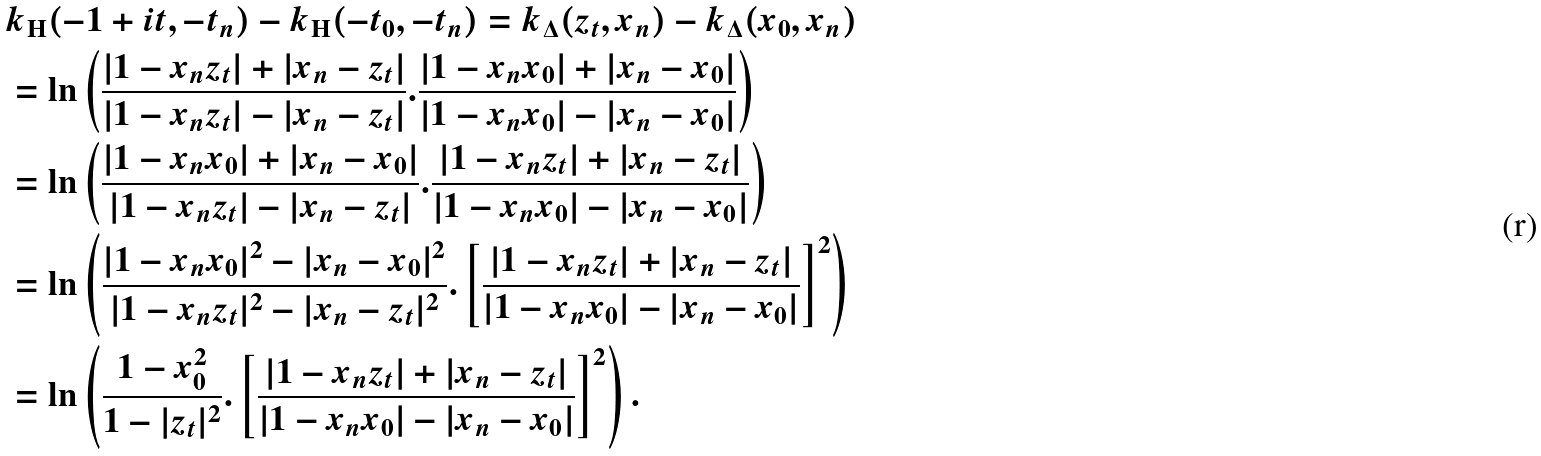<formula> <loc_0><loc_0><loc_500><loc_500>& k _ { \mathrm H } ( - 1 + i t , - t _ { n } ) - k _ { \mathrm H } ( - t _ { 0 } , - t _ { n } ) = k _ { \Delta } ( z _ { t } , x _ { n } ) - k _ { \Delta } ( x _ { 0 } , x _ { n } ) \\ & = \ln \left ( \frac { | 1 - x _ { n } z _ { t } | + | x _ { n } - z _ { t } | } { | 1 - x _ { n } z _ { t } | - | x _ { n } - z _ { t } | } . \frac { | 1 - x _ { n } x _ { 0 } | + | x _ { n } - x _ { 0 } | } { | 1 - x _ { n } x _ { 0 } | - | x _ { n } - x _ { 0 } | } \right ) \\ & = \ln \left ( \frac { | 1 - x _ { n } x _ { 0 } | + | x _ { n } - x _ { 0 } | } { | 1 - x _ { n } z _ { t } | - | x _ { n } - z _ { t } | } . \frac { | 1 - x _ { n } z _ { t } | + | x _ { n } - z _ { t } | } { | 1 - x _ { n } x _ { 0 } | - | x _ { n } - x _ { 0 } | } \right ) \\ & = \ln \left ( \frac { | 1 - x _ { n } x _ { 0 } | ^ { 2 } - | x _ { n } - x _ { 0 } | ^ { 2 } } { | 1 - x _ { n } z _ { t } | ^ { 2 } - | x _ { n } - z _ { t } | ^ { 2 } } . \left [ \frac { | 1 - x _ { n } z _ { t } | + | x _ { n } - z _ { t } | } { | 1 - x _ { n } x _ { 0 } | - | x _ { n } - x _ { 0 } | } \right ] ^ { 2 } \right ) \\ & = \ln \left ( \frac { 1 - x _ { 0 } ^ { 2 } } { 1 - | z _ { t } | ^ { 2 } } . \left [ \frac { | 1 - x _ { n } z _ { t } | + | x _ { n } - z _ { t } | } { | 1 - x _ { n } x _ { 0 } | - | x _ { n } - x _ { 0 } | } \right ] ^ { 2 } \right ) .</formula> 